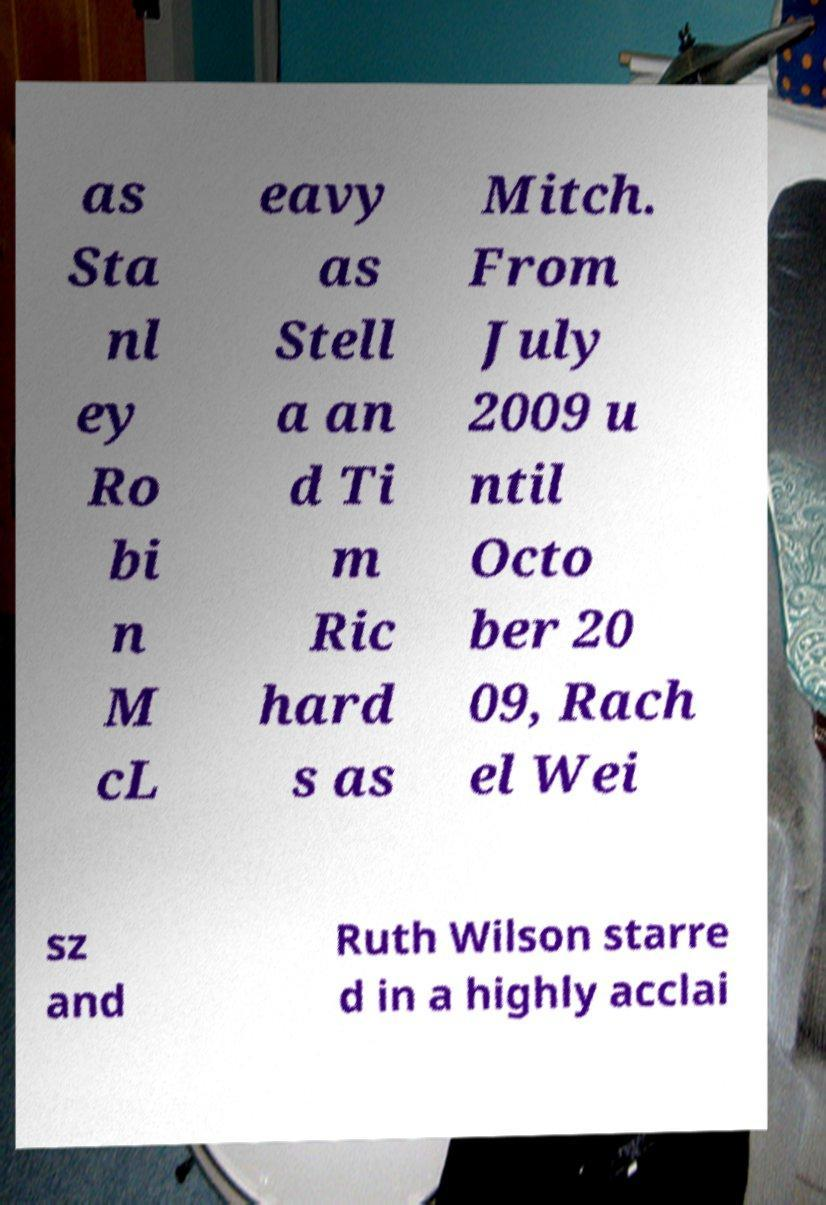For documentation purposes, I need the text within this image transcribed. Could you provide that? as Sta nl ey Ro bi n M cL eavy as Stell a an d Ti m Ric hard s as Mitch. From July 2009 u ntil Octo ber 20 09, Rach el Wei sz and Ruth Wilson starre d in a highly acclai 